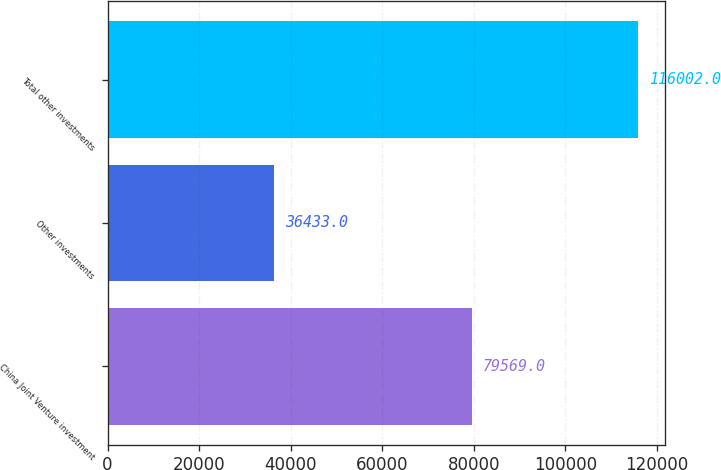Convert chart to OTSL. <chart><loc_0><loc_0><loc_500><loc_500><bar_chart><fcel>China Joint Venture investment<fcel>Other investments<fcel>Total other investments<nl><fcel>79569<fcel>36433<fcel>116002<nl></chart> 